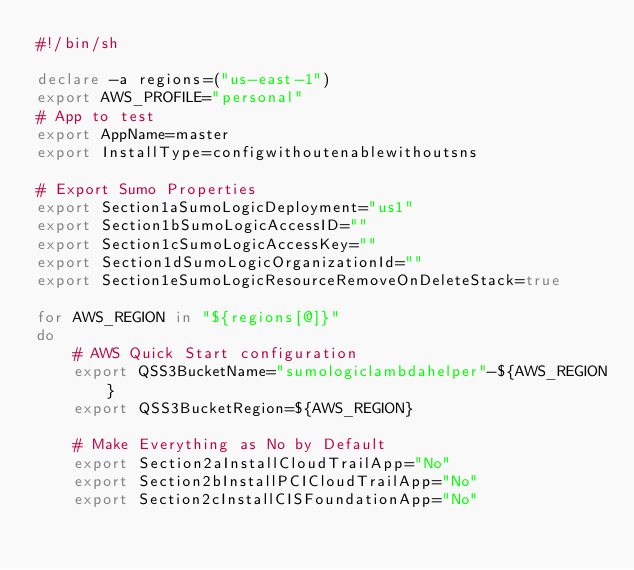<code> <loc_0><loc_0><loc_500><loc_500><_Bash_>#!/bin/sh

declare -a regions=("us-east-1")
export AWS_PROFILE="personal"
# App to test
export AppName=master
export InstallType=configwithoutenablewithoutsns

# Export Sumo Properties
export Section1aSumoLogicDeployment="us1"
export Section1bSumoLogicAccessID=""
export Section1cSumoLogicAccessKey=""
export Section1dSumoLogicOrganizationId=""
export Section1eSumoLogicResourceRemoveOnDeleteStack=true

for AWS_REGION in "${regions[@]}"
do
    # AWS Quick Start configuration
    export QSS3BucketName="sumologiclambdahelper"-${AWS_REGION}
    export QSS3BucketRegion=${AWS_REGION}

    # Make Everything as No by Default
    export Section2aInstallCloudTrailApp="No"
    export Section2bInstallPCICloudTrailApp="No"
    export Section2cInstallCISFoundationApp="No"</code> 